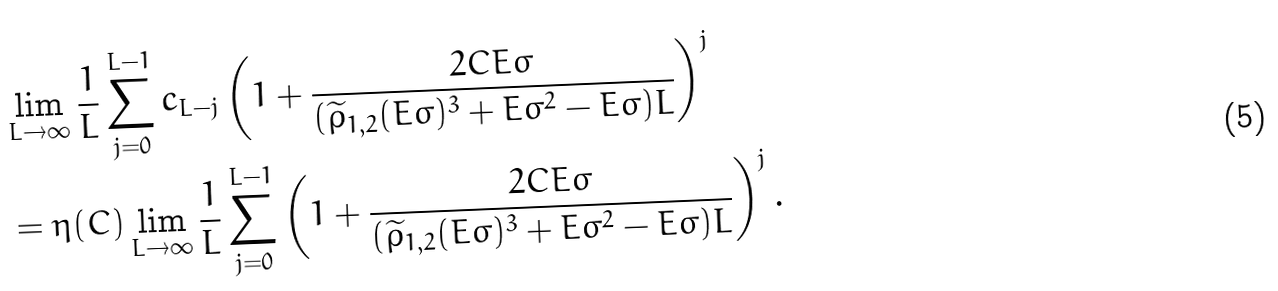<formula> <loc_0><loc_0><loc_500><loc_500>& \lim _ { L \to \infty } \frac { 1 } { L } \sum _ { j = 0 } ^ { L - 1 } c _ { L - j } \left ( 1 + \frac { 2 C E \varsigma } { ( \widetilde { \rho } _ { 1 , 2 } ( E \varsigma ) ^ { 3 } + E \varsigma ^ { 2 } - E \varsigma ) L } \right ) ^ { j } \\ & = \eta ( C ) \lim _ { L \to \infty } \frac { 1 } { L } \sum _ { j = 0 } ^ { L - 1 } \left ( 1 + \frac { 2 C E \varsigma } { ( \widetilde { \rho } _ { 1 , 2 } ( E \varsigma ) ^ { 3 } + E \varsigma ^ { 2 } - E \varsigma ) L } \right ) ^ { j } .</formula> 